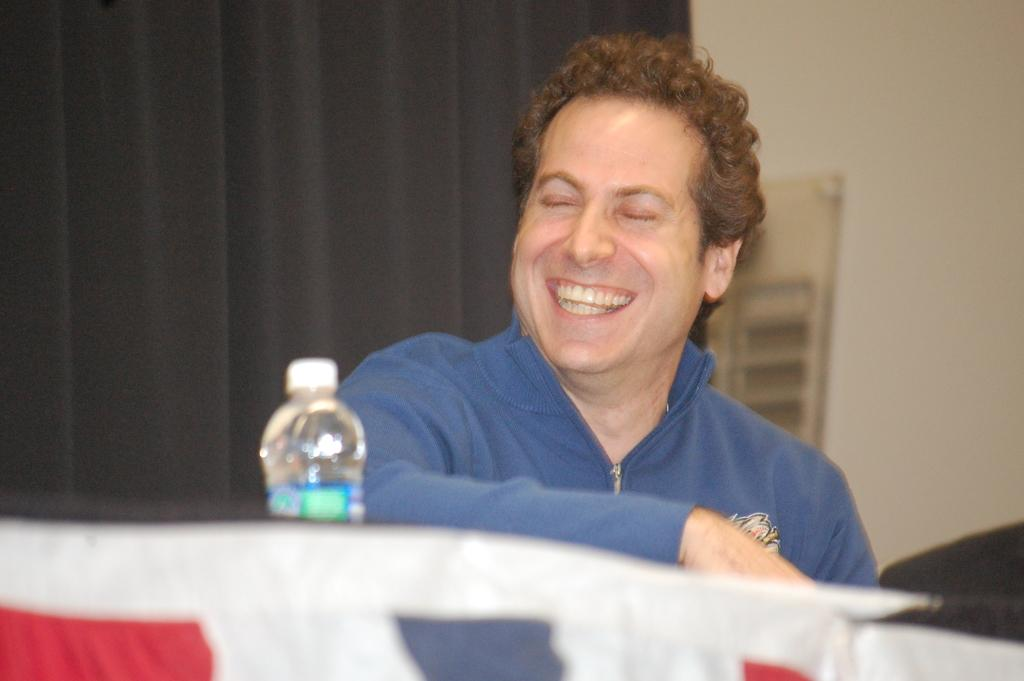Who is present in the image? There is a man in the image. What is the man wearing? The man is wearing a blue jacket. What expression does the man have? The man has a smile on his face. What can be seen in the image besides the man? There is a water bottle in the image. What type of grass can be seen growing near the man in the image? There is no grass visible in the image; it appears to be an indoor setting. 